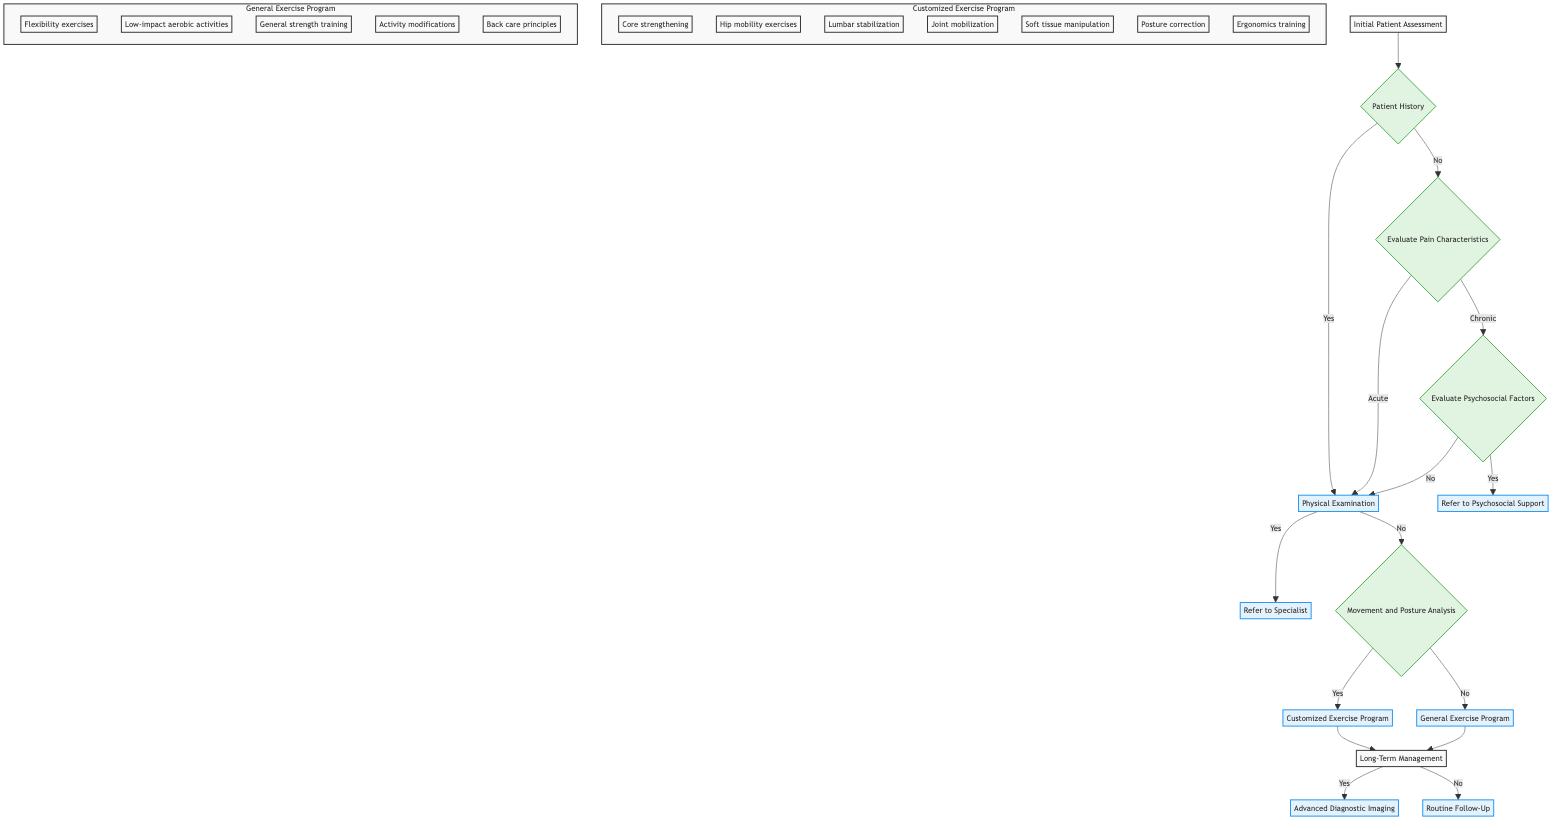What is the first step according to the diagram? The diagram starts with "Initial Patient Assessment" as the first step. This is indicated at the top of the decision tree.
Answer: Initial Patient Assessment How many main decision nodes are there in the diagram? The main decision nodes are "Patient History," "Evaluate Pain Characteristics," "Evaluate Psychosocial Factors," "Physical Examination," and "Movement and Posture Analysis," totaling five nodes.
Answer: 5 If a patient has chronic pain, what is the next step? If the patient has chronic pain, the next step is "Evaluate Psychosocial Factors," which is the decision point following the "Evaluate Pain Characteristics" node.
Answer: Evaluate Psychosocial Factors What happens if there are neurological deficits? If there are neurological deficits identified during the Physical Examination, the flow directs to "Refer to Specialist," indicating further specialized care is needed.
Answer: Refer to Specialist What interventions are included in the Customized Exercise Program? The interventions listed in the Customized Exercise Program include core strengthening, hip mobility exercises, lumbar stabilization techniques, joint mobilization, soft tissue manipulation, and posture correction/ergonomics training.
Answer: Core strengthening, hip mobility exercises, lumbar stabilization techniques, joint mobilization, soft tissue manipulation, posture correction, ergonomics training What is the outcome if there is persistent pain after three months? If there is persistent pain after three months, the outcome is "Advanced Diagnostic Imaging," leading to possible further investigation through imaging techniques.
Answer: Advanced Diagnostic Imaging Which program is chosen if no abnormal movement is noted? If no abnormal movement or posture is noted during the Movement and Posture Analysis, the program chosen is "General Exercise Program," indicating a focus on less customized strategies.
Answer: General Exercise Program What type of monitoring is included in Routine Follow-Up? The Routine Follow-Up includes "Regular assessments to monitor progress and adjust treatment plan," ensuring the patient’s continuous improvement is tracked over time.
Answer: Regular assessments to monitor progress and adjust treatment plan What referral is suggested if psychological distress is present? If there are signs of psychological distress, the suggested referral is to "Refer to Psychosocial Support," which indicates addressing mental health as part of the overall management plan.
Answer: Refer to Psychosocial Support 